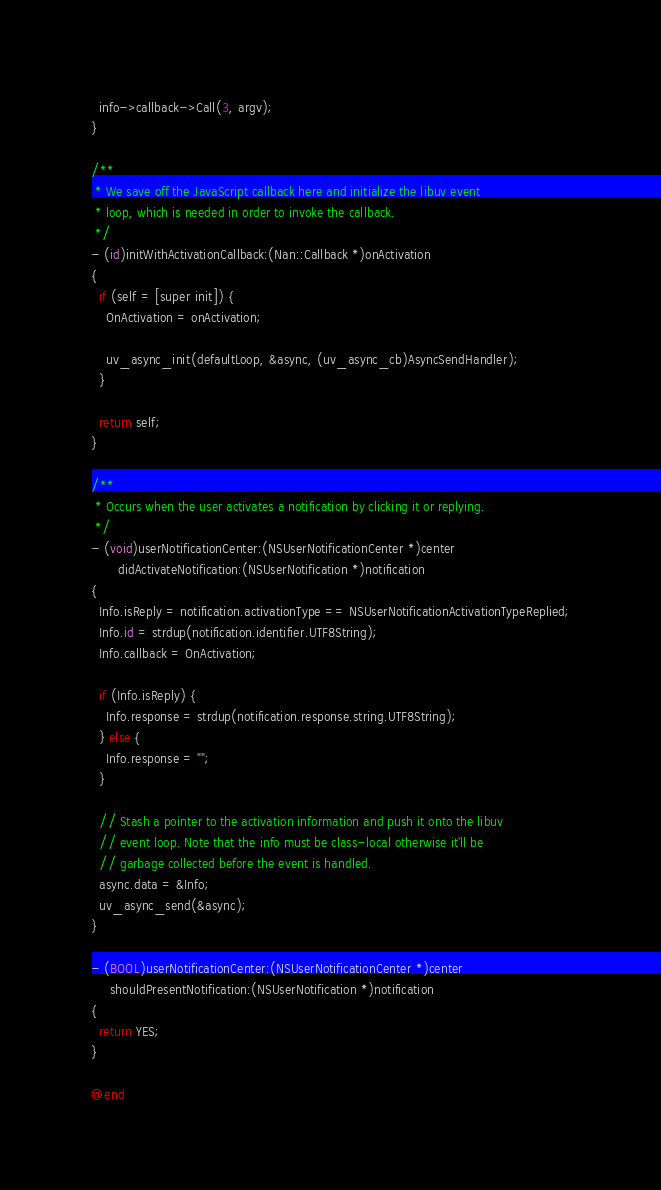Convert code to text. <code><loc_0><loc_0><loc_500><loc_500><_ObjectiveC_>
  info->callback->Call(3, argv);
}

/**
 * We save off the JavaScript callback here and initialize the libuv event
 * loop, which is needed in order to invoke the callback.
 */
- (id)initWithActivationCallback:(Nan::Callback *)onActivation
{
  if (self = [super init]) {
    OnActivation = onActivation;

    uv_async_init(defaultLoop, &async, (uv_async_cb)AsyncSendHandler);
  }

  return self;
}

/**
 * Occurs when the user activates a notification by clicking it or replying.
 */
- (void)userNotificationCenter:(NSUserNotificationCenter *)center
       didActivateNotification:(NSUserNotification *)notification
{
  Info.isReply = notification.activationType == NSUserNotificationActivationTypeReplied;
  Info.id = strdup(notification.identifier.UTF8String);
  Info.callback = OnActivation;

  if (Info.isReply) {
    Info.response = strdup(notification.response.string.UTF8String);
  } else {
    Info.response = "";
  }

  // Stash a pointer to the activation information and push it onto the libuv
  // event loop. Note that the info must be class-local otherwise it'll be
  // garbage collected before the event is handled.
  async.data = &Info;
  uv_async_send(&async);
}

- (BOOL)userNotificationCenter:(NSUserNotificationCenter *)center
     shouldPresentNotification:(NSUserNotification *)notification
{
  return YES;
}

@end
</code> 